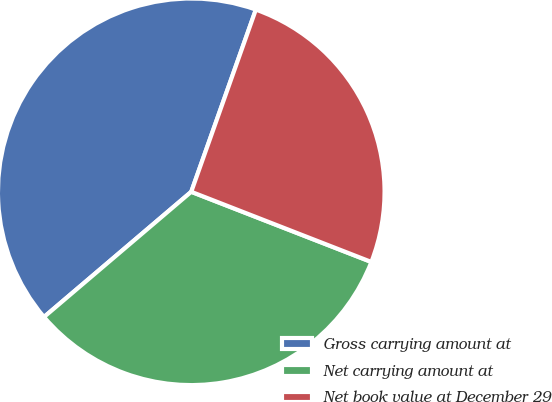Convert chart to OTSL. <chart><loc_0><loc_0><loc_500><loc_500><pie_chart><fcel>Gross carrying amount at<fcel>Net carrying amount at<fcel>Net book value at December 29<nl><fcel>41.64%<fcel>32.87%<fcel>25.49%<nl></chart> 